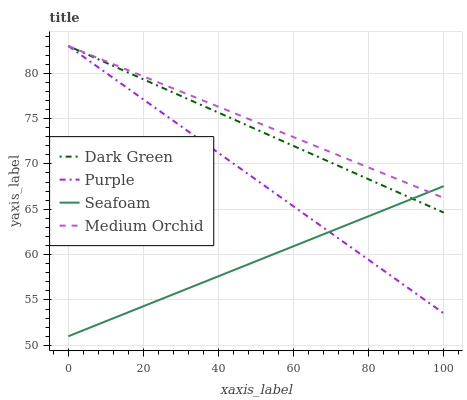Does Seafoam have the minimum area under the curve?
Answer yes or no. Yes. Does Medium Orchid have the maximum area under the curve?
Answer yes or no. Yes. Does Medium Orchid have the minimum area under the curve?
Answer yes or no. No. Does Seafoam have the maximum area under the curve?
Answer yes or no. No. Is Dark Green the smoothest?
Answer yes or no. Yes. Is Purple the roughest?
Answer yes or no. Yes. Is Medium Orchid the smoothest?
Answer yes or no. No. Is Medium Orchid the roughest?
Answer yes or no. No. Does Seafoam have the lowest value?
Answer yes or no. Yes. Does Medium Orchid have the lowest value?
Answer yes or no. No. Does Dark Green have the highest value?
Answer yes or no. Yes. Does Seafoam have the highest value?
Answer yes or no. No. Does Purple intersect Dark Green?
Answer yes or no. Yes. Is Purple less than Dark Green?
Answer yes or no. No. Is Purple greater than Dark Green?
Answer yes or no. No. 